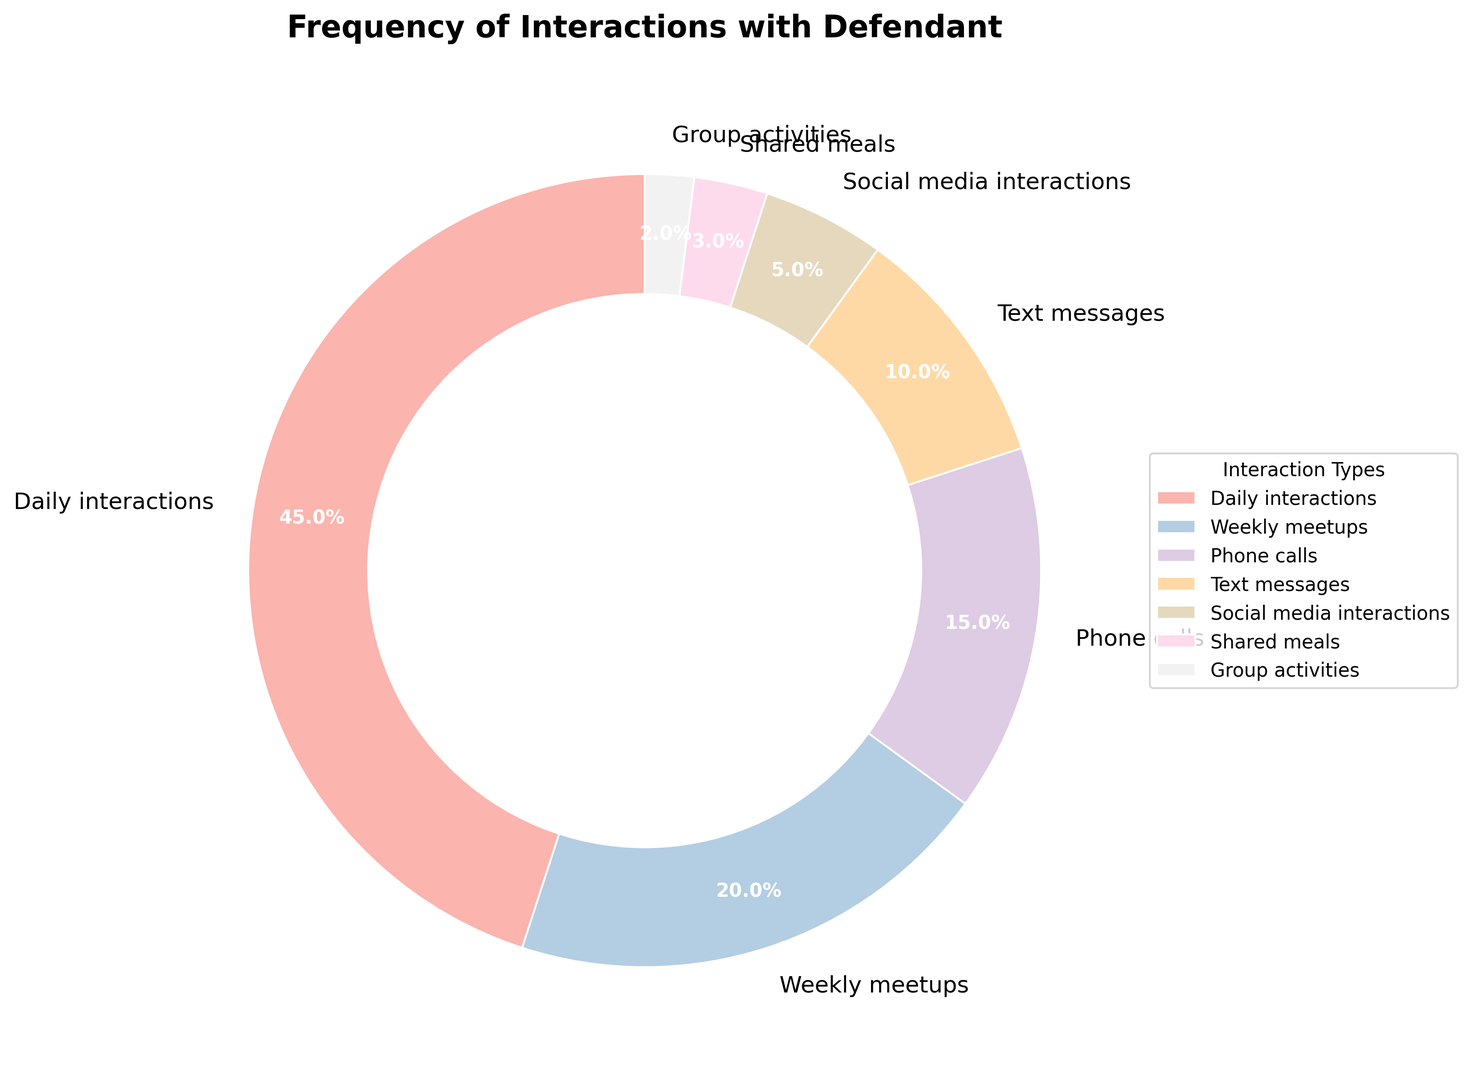What is the most frequent type of interaction? The most frequent type of interaction will have the largest portion in the pie chart. The "Daily interactions" slice is the largest.
Answer: Daily interactions Which type of interaction occurs the least? The least frequent type of interaction will have the smallest portion in the pie chart. The "Group activities" slice is the smallest.
Answer: Group activities Are 'Phone calls' more frequent than 'Text messages'? By looking at the sizes of the slices, the "Phone calls" slice is larger than the "Text messages" slice.
Answer: Yes What is the combined percentage of "Weekly meetups" and "Shared meals"? Sum the percentages of "Weekly meetups" and "Shared meals". "Weekly meetups" have 20%, and "Shared meals" have 3%. So, 20% + 3% = 23%.
Answer: 23% Which slice is colored the lightest? The lightest color on a pie chart slice, often appears in the first portion of the pastel color scale, belongs to "Social media interactions" in this chart.
Answer: Social media interactions How does the frequency of 'Text messages' compare to 'Social media interactions'? Compare the sizes of the slices for "Text messages" and "Social media interactions". The "Text messages" slice is larger than the "Social media interactions" slice.
Answer: Text messages are more frequent Which section occupies a quarter of the chart? Look for a slice that is around 25% of the pie chart. "Daily interactions" has 45%, much larger; "Weekly meetups" are 20%, a bit smaller. None directly occupy a quarter.
Answer: None Which two categories combined make up the largest percentage? Add percentages of different combinations and compare them. "Daily interactions" 45% + "Weekly meetups" 20% = 65%, which is the largest combined percentage.
Answer: Daily interactions and Weekly meetups If you combine 'Text messages', 'Social media interactions', and 'Shared meals', does their total exceed 'Phone calls'? Sum the percentages of 'Text messages' (10%), 'Social media interactions' (5%), and 'Shared meals' (3%). 10% + 5% + 3% = 18%, which is greater than the 'Phone calls' sharing of 15%.
Answer: Yes Looking at the pie chart's structure, what would you estimate is the average percentage share per category? To find the average, add all the percentages (45% + 20% + 15% + 10% + 5% + 3% + 2%) giving 100%, and divide by the number of categories, 7. So, 100% / 7 ≈ 14.3%.
Answer: 14.3% 